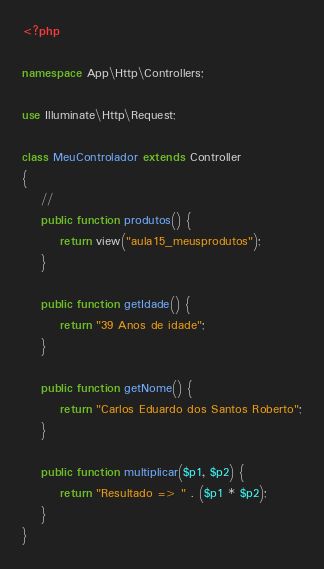<code> <loc_0><loc_0><loc_500><loc_500><_PHP_><?php

namespace App\Http\Controllers;

use Illuminate\Http\Request;

class MeuControlador extends Controller
{
    //
    public function produtos() {
        return view("aula15_meusprodutos");
    }

    public function getIdade() {
        return "39 Anos de idade";
    }

    public function getNome() {
        return "Carlos Eduardo dos Santos Roberto";
    }

    public function multiplicar($p1, $p2) {
        return "Resultado => " . ($p1 * $p2);
    }
}
</code> 